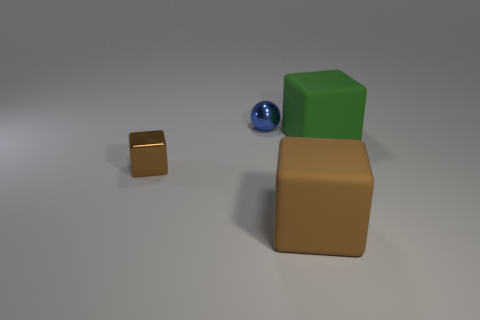Are the tiny brown block and the small thing behind the tiny brown metallic cube made of the same material?
Keep it short and to the point. Yes. What is the material of the small sphere?
Give a very brief answer. Metal. How many other objects are there of the same material as the small brown thing?
Your answer should be compact. 1. There is a object that is behind the tiny brown shiny block and on the left side of the green thing; what shape is it?
Ensure brevity in your answer.  Sphere. There is a object that is made of the same material as the tiny blue ball; what is its color?
Your response must be concise. Brown. Are there an equal number of green things to the left of the big green rubber block and big green cylinders?
Provide a short and direct response. Yes. There is a shiny thing that is the same size as the metal sphere; what shape is it?
Provide a succinct answer. Cube. How many other things are the same shape as the tiny brown object?
Your answer should be very brief. 2. There is a shiny ball; is its size the same as the brown block that is to the left of the blue metal thing?
Provide a succinct answer. Yes. What number of objects are large rubber objects on the left side of the large green rubber cube or big green rubber things?
Provide a succinct answer. 2. 